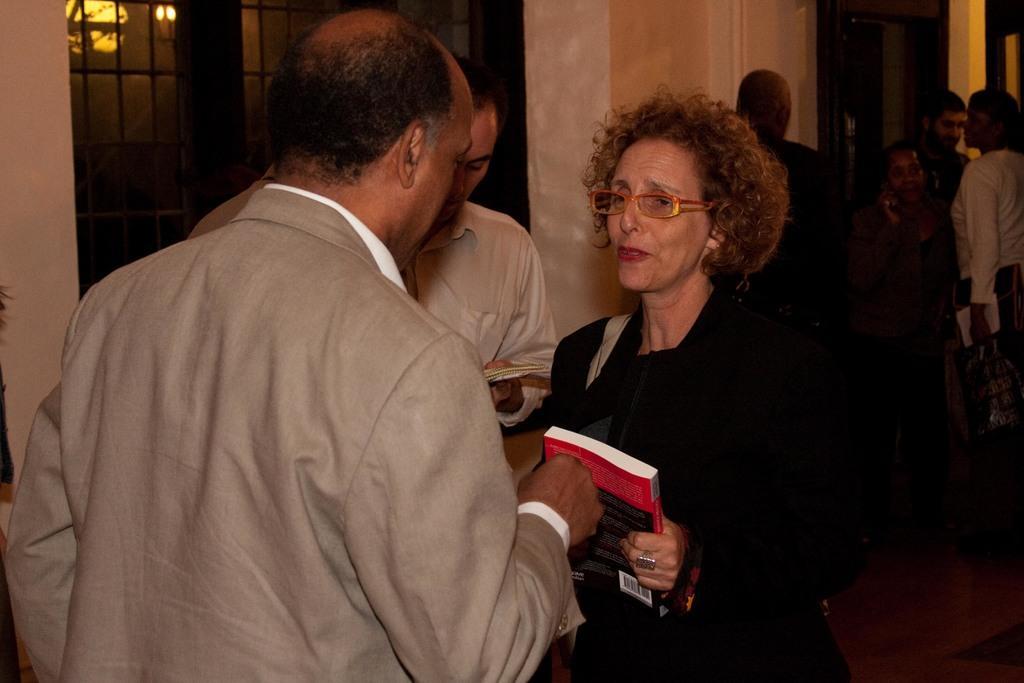Can you describe this image briefly? Here we can see few persons. She holding a book with her hand and she has spectacles. In the background we can see wall, lights, and glasses. 